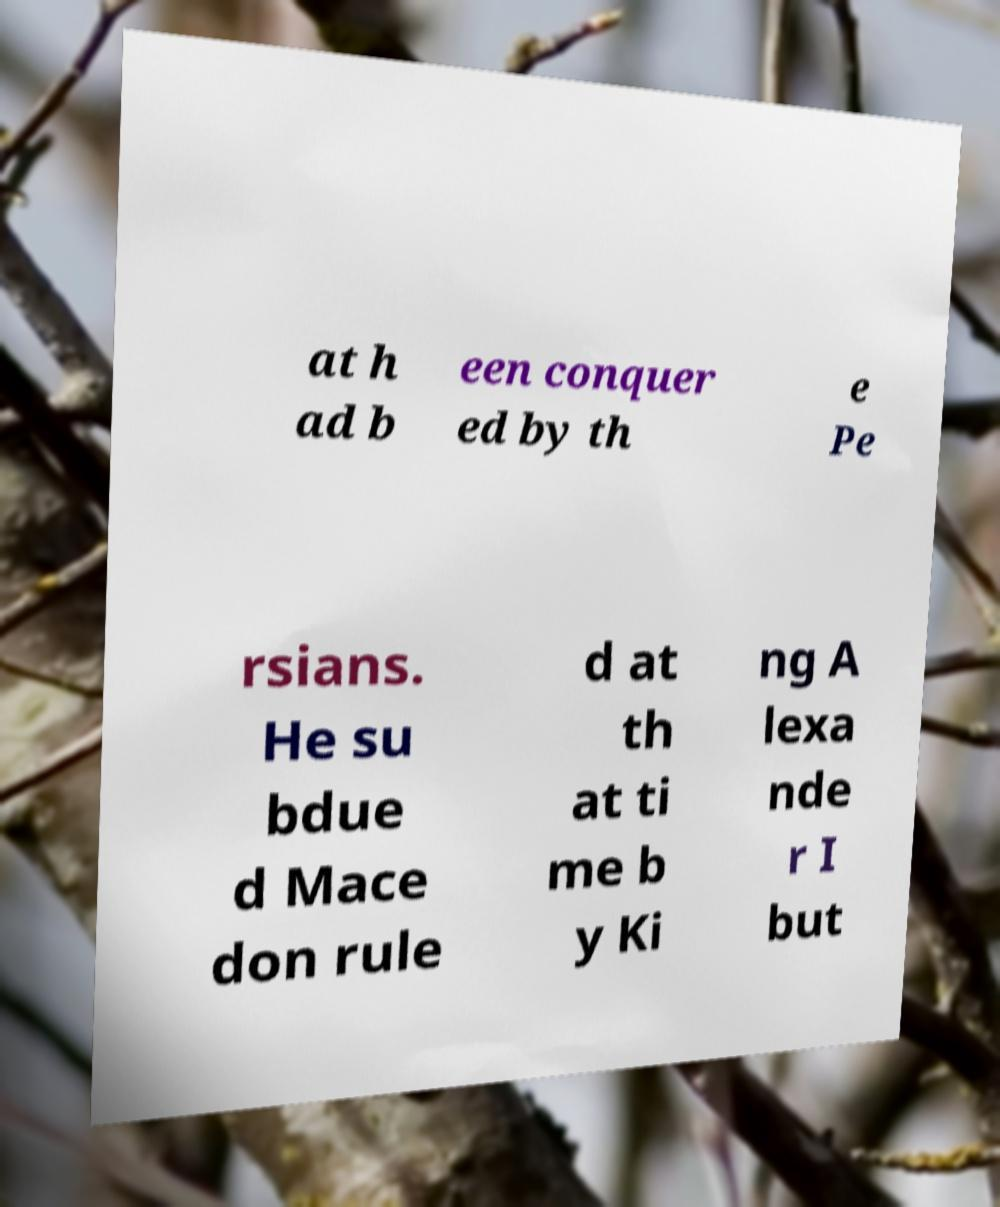Can you accurately transcribe the text from the provided image for me? at h ad b een conquer ed by th e Pe rsians. He su bdue d Mace don rule d at th at ti me b y Ki ng A lexa nde r I but 